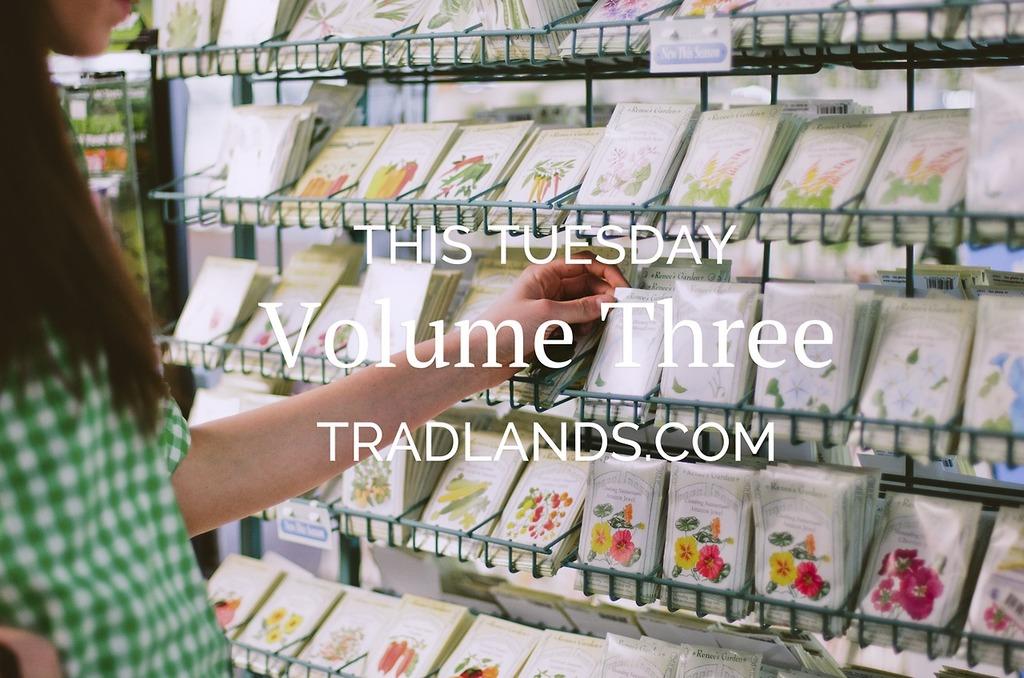What website is this from?
Your answer should be compact. Tradlands.com. 